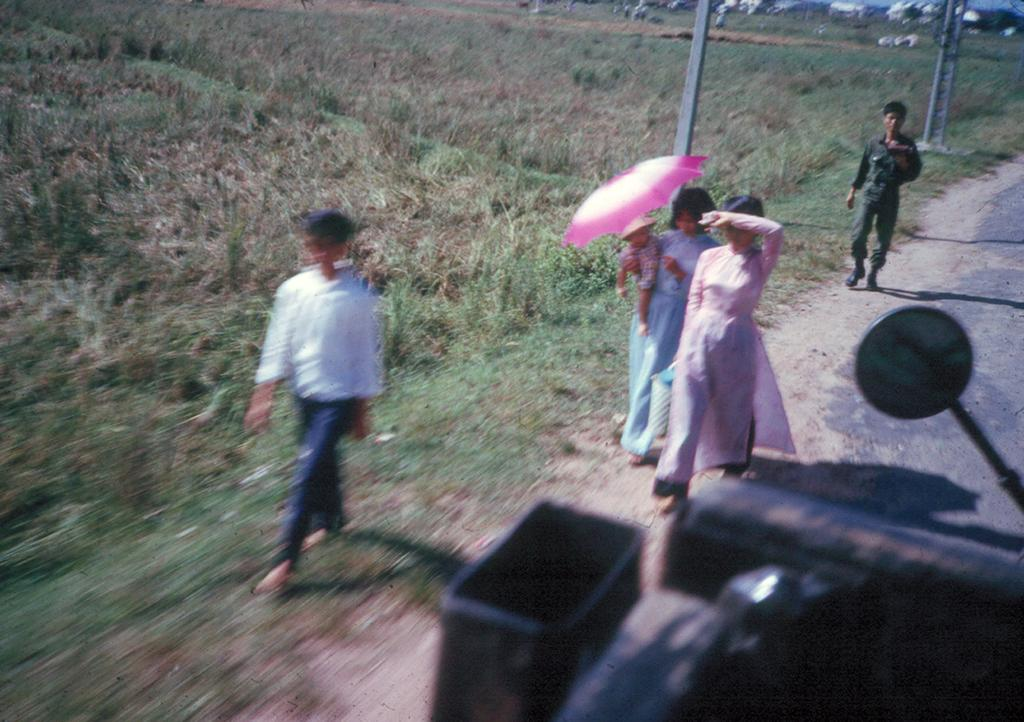What are the people in the image doing? The people in the image are walking on the road. What can be seen in the background of the image? There is grassy land and poles in the background. Is there any uncertainty about an object in the image? Yes, there might be a vehicle in the right bottom of the image, but this is less certain and should be considered tentative. What type of suit is the partner wearing in the image? There is no partner or suit present in the image; it features people walking on the road with a grassy background and poles. 